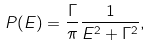<formula> <loc_0><loc_0><loc_500><loc_500>P ( E ) = \frac { \Gamma } { \pi } \frac { 1 } { E ^ { 2 } + \Gamma ^ { 2 } } ,</formula> 